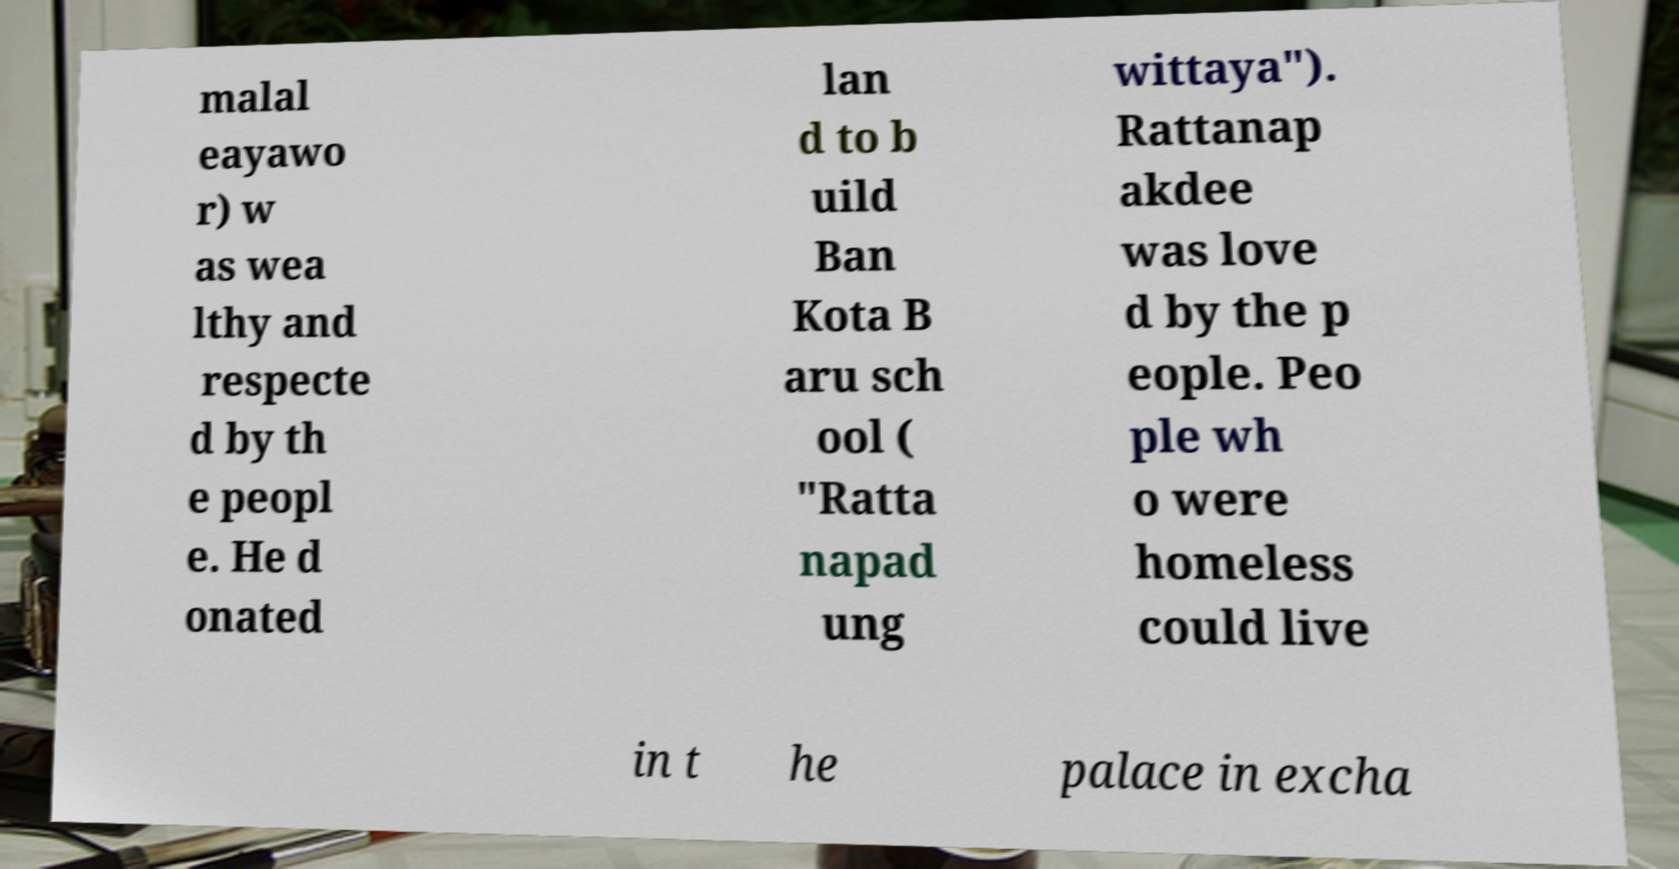Please identify and transcribe the text found in this image. malal eayawo r) w as wea lthy and respecte d by th e peopl e. He d onated lan d to b uild Ban Kota B aru sch ool ( "Ratta napad ung wittaya"). Rattanap akdee was love d by the p eople. Peo ple wh o were homeless could live in t he palace in excha 